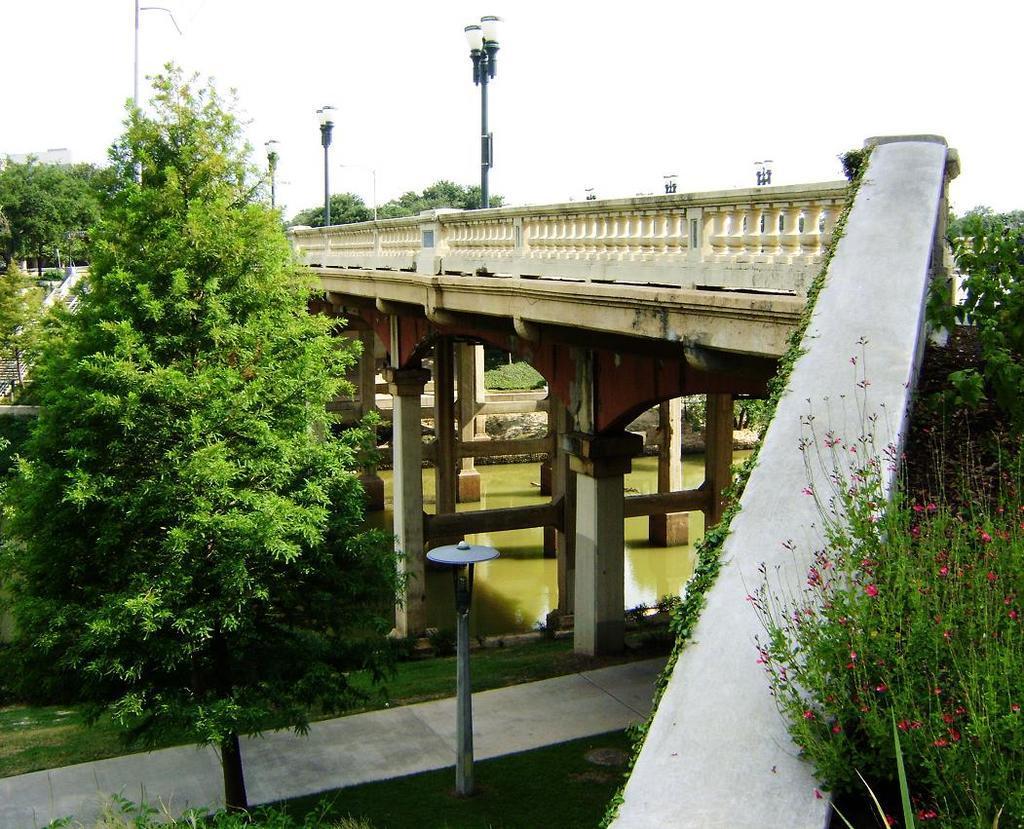Could you give a brief overview of what you see in this image? In this image we can see a bridge on the river, street poles, street lights, trees, staircase, stones, ground and sky. 